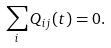<formula> <loc_0><loc_0><loc_500><loc_500>\sum _ { i } Q _ { i j } ( t ) = 0 .</formula> 